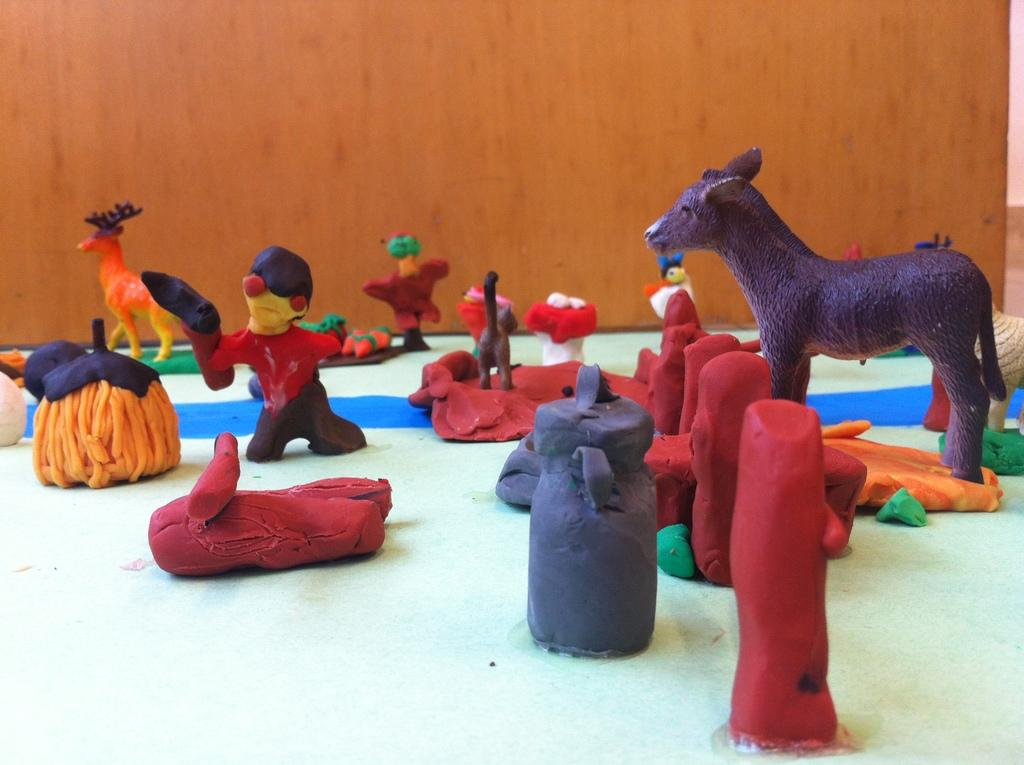What type of objects are in the center of the image? There are colorful toys in the center of the image. What kind of toys are included in the image? The toys include animals, poles, and cans. What material are the toys made of? The toys are made of clay. What can be seen in the background of the image? There is a wall in the background of the image. What type of bubble can be seen floating near the toys in the image? There is no bubble present in the image; it only features colorful clay toys. 